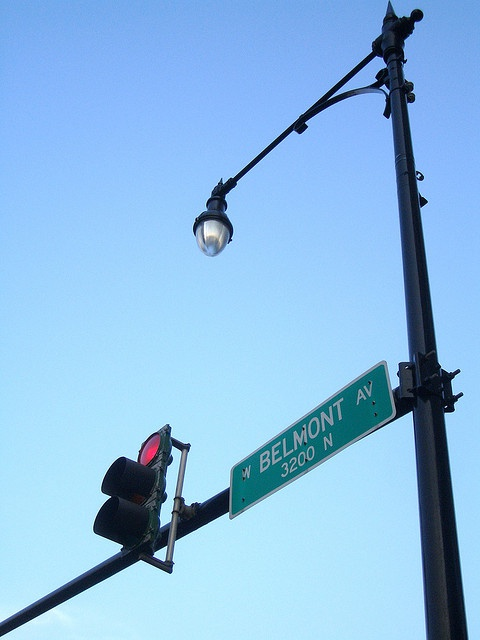Describe the objects in this image and their specific colors. I can see a traffic light in lightblue, black, navy, blue, and gray tones in this image. 